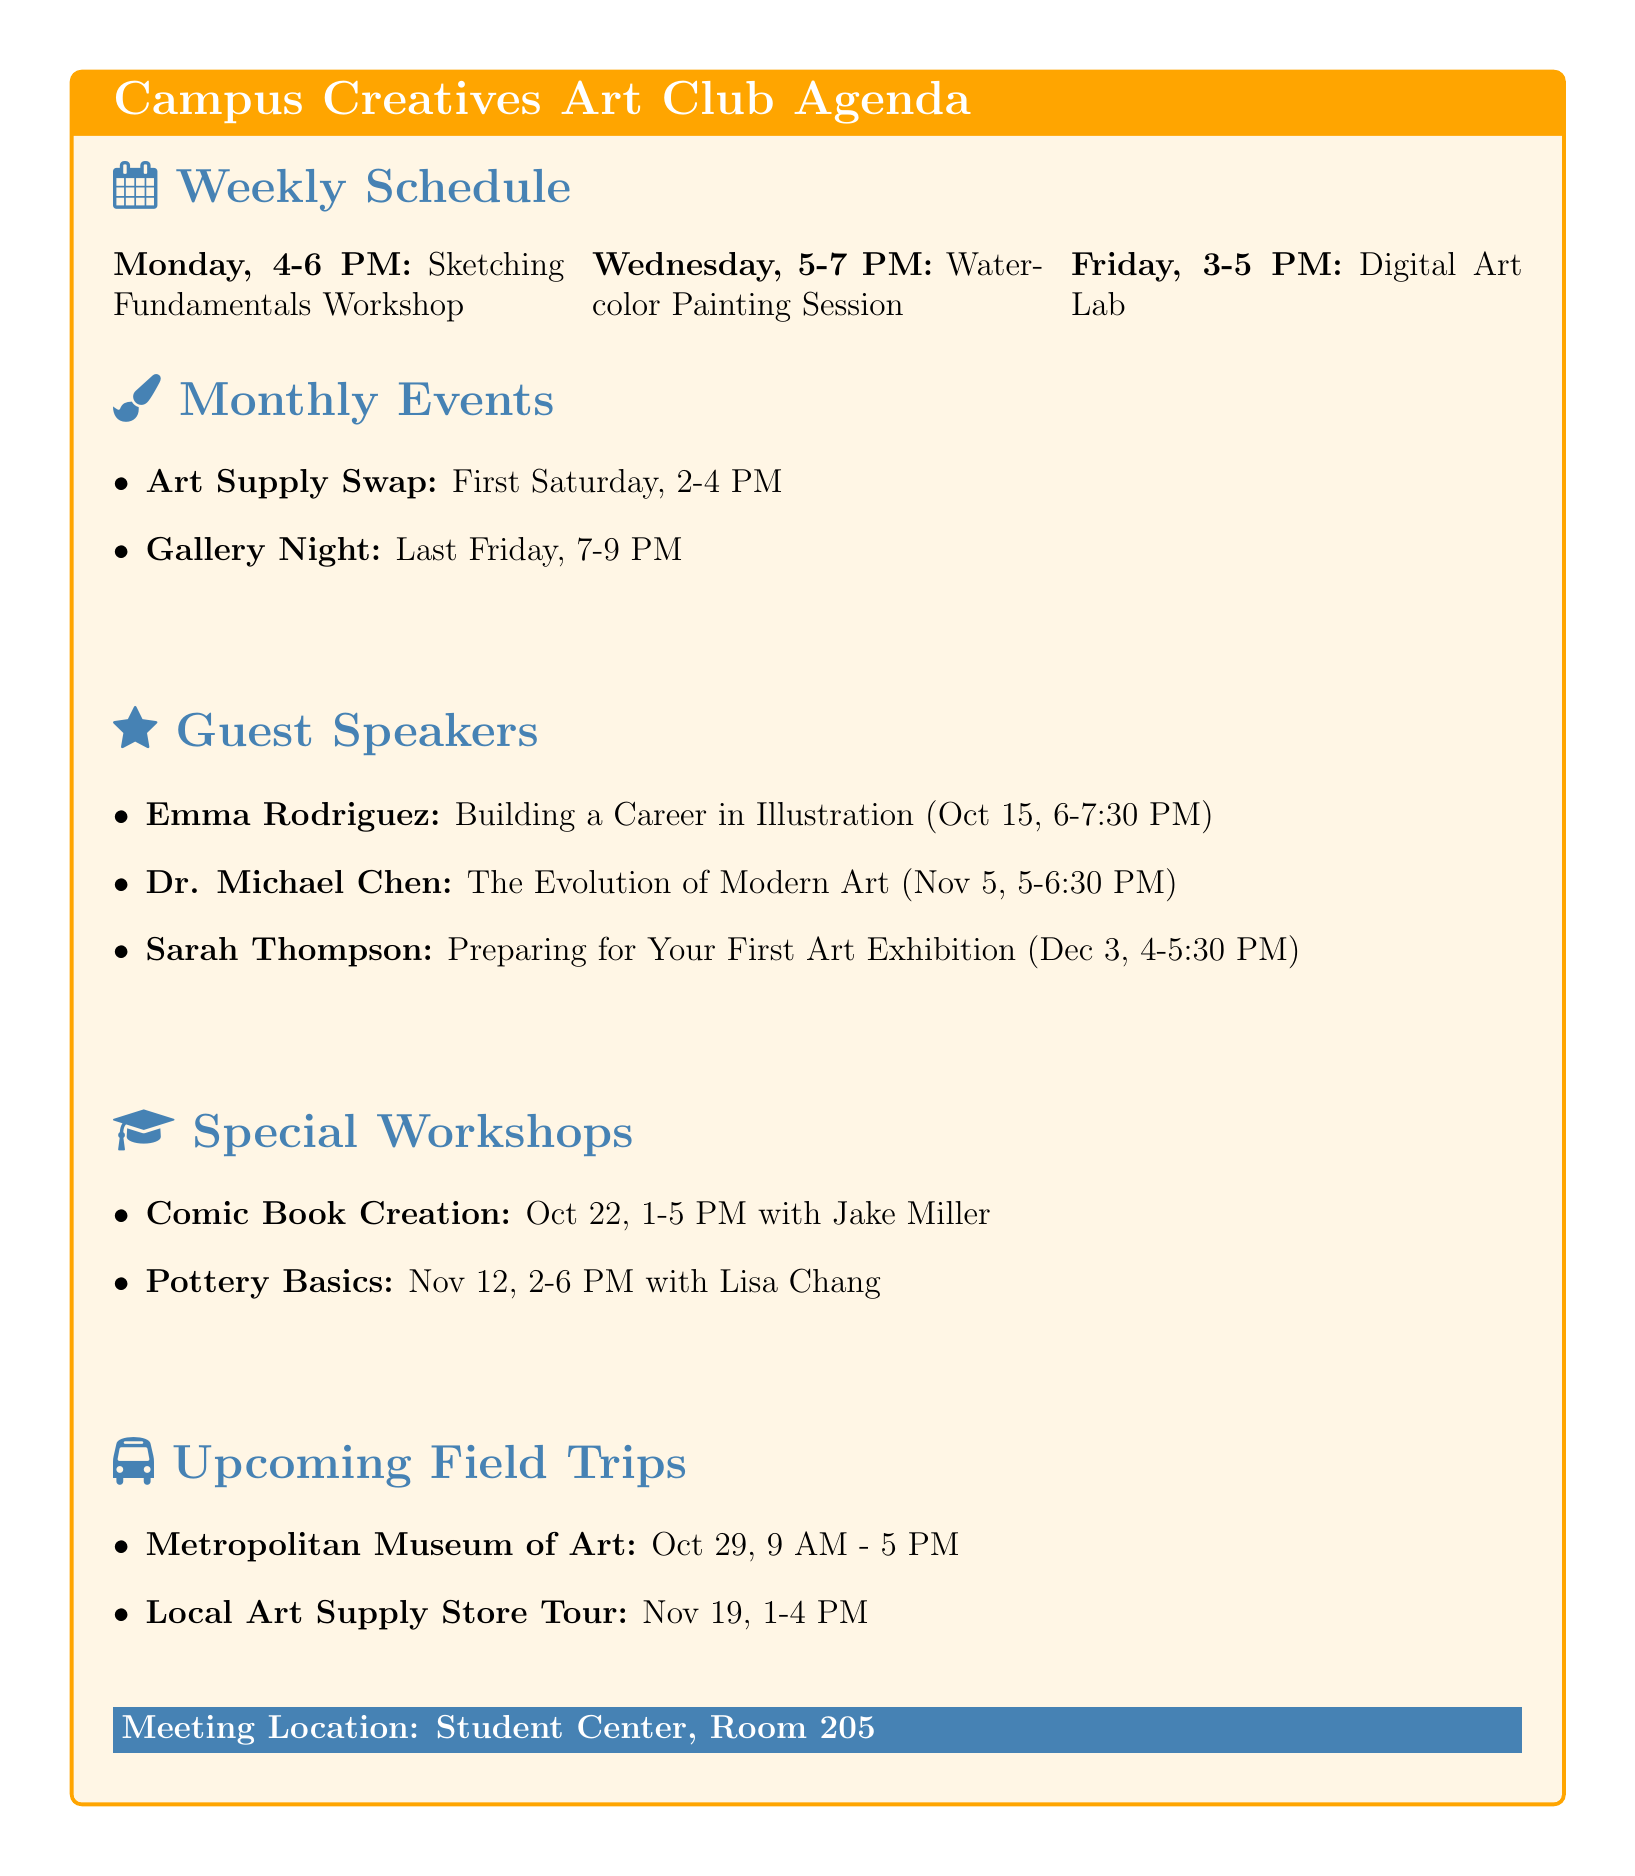What is the name of the club? The name of the club is stated clearly in the document.
Answer: Campus Creatives Art Club When does the Watercolor Painting Session occur? The specific day and time are listed in the weekly schedule.
Answer: Wednesday, 5:00 PM - 7:00 PM Who is the guest speaker on October 15, 2023? This information is given in the guest speakers section with the corresponding date.
Answer: Emma Rodriguez What activity is planned for the first Saturday of every month? The monthly events section indicates this event clearly.
Answer: Art Supply Swap How long does the Comic Book Creation Workshop last? The duration of the workshop is provided in the specials section of the agenda.
Answer: 4 hours What is the meeting time for the field trip to the Metropolitan Museum of Art? The scheduled meeting time is specified in the upcoming field trips section.
Answer: 9:00 AM Who is conducting the Pottery Basics workshop? The instructor's name is listed next to the workshop in the specials section.
Answer: Lisa Chang What is the name of the room where meetings are held? This information is stated at the end of the document.
Answer: Room 205 How many guest speakers are scheduled for the upcoming months? The number can be determined by counting the entries in the guest speakers section.
Answer: 3 